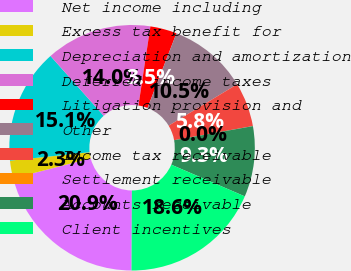Convert chart to OTSL. <chart><loc_0><loc_0><loc_500><loc_500><pie_chart><fcel>Net income including<fcel>Excess tax benefit for<fcel>Depreciation and amortization<fcel>Deferred income taxes<fcel>Litigation provision and<fcel>Other<fcel>Income tax receivable<fcel>Settlement receivable<fcel>Accounts receivable<fcel>Client incentives<nl><fcel>20.92%<fcel>2.33%<fcel>15.11%<fcel>13.95%<fcel>3.5%<fcel>10.46%<fcel>5.82%<fcel>0.01%<fcel>9.3%<fcel>18.59%<nl></chart> 